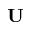Convert formula to latex. <formula><loc_0><loc_0><loc_500><loc_500>U</formula> 